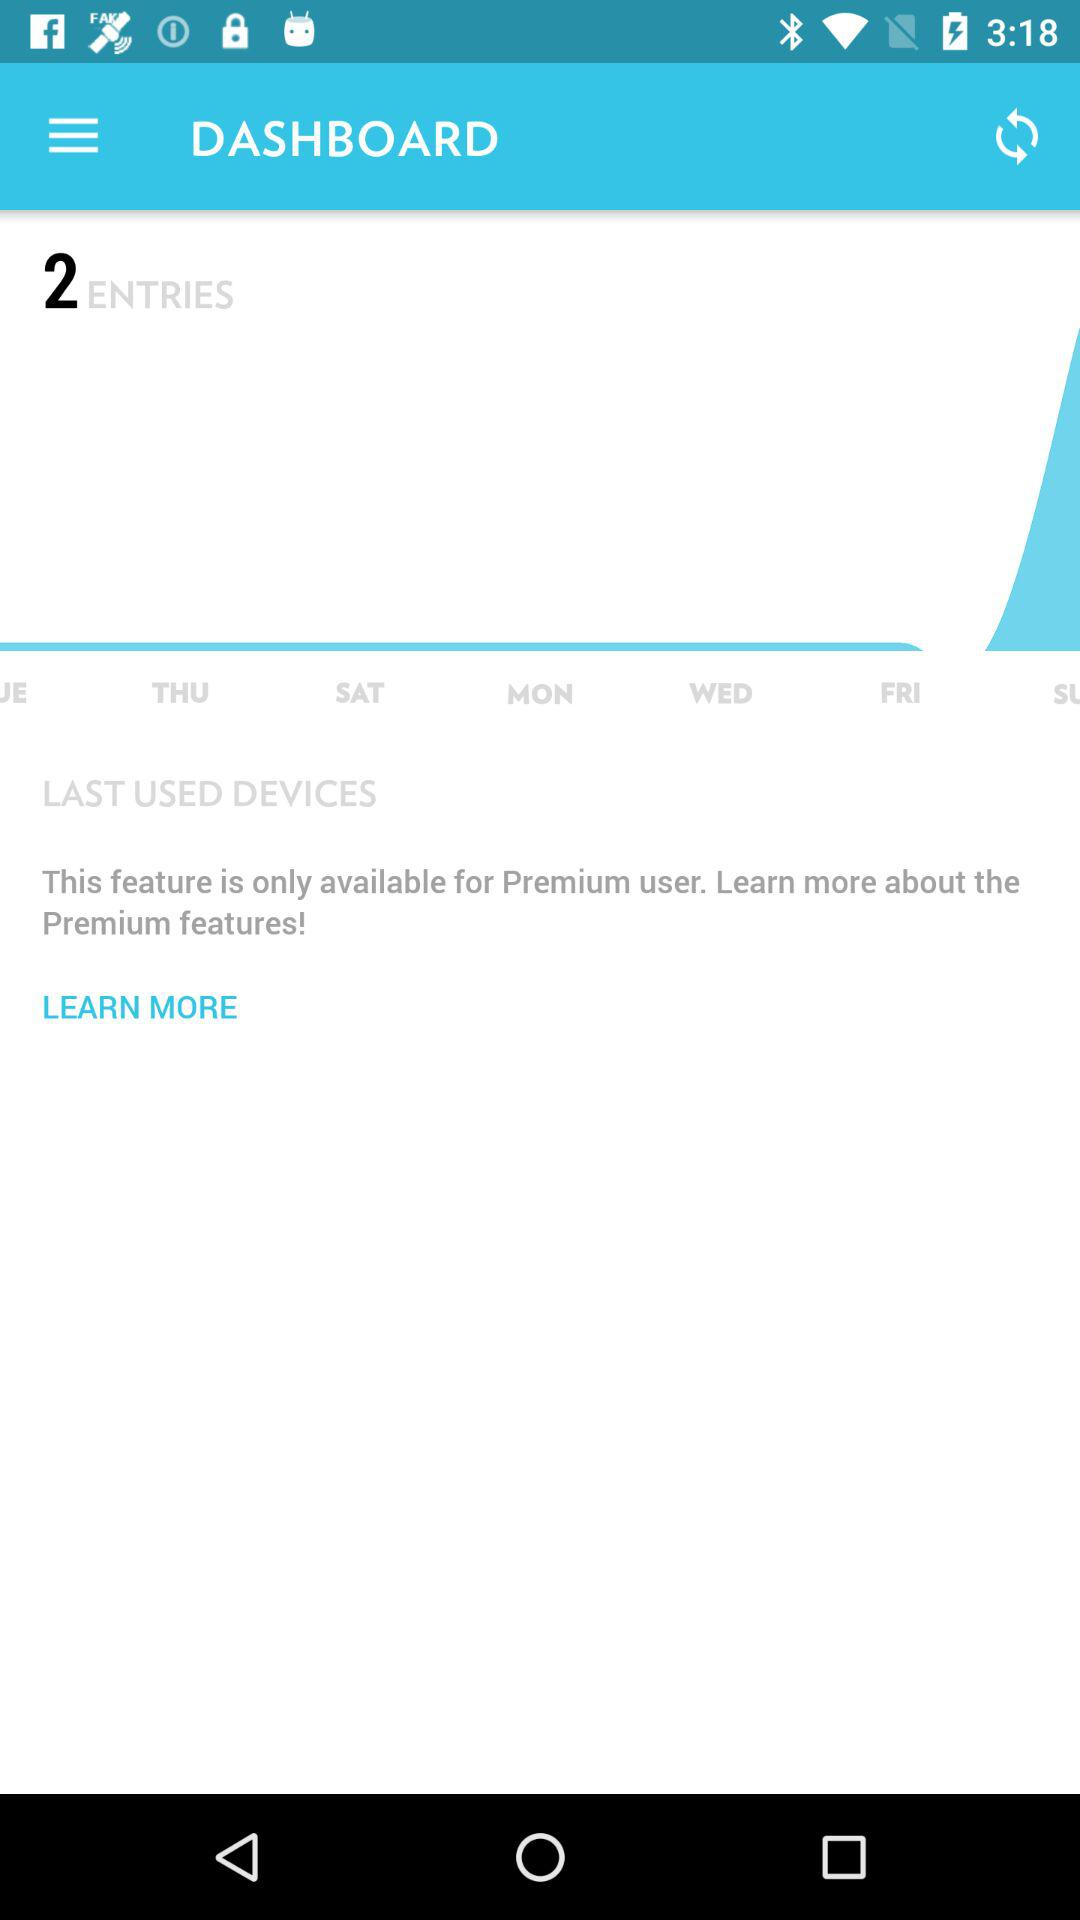How many entries are there in the dashboard? There are 2 entries. 